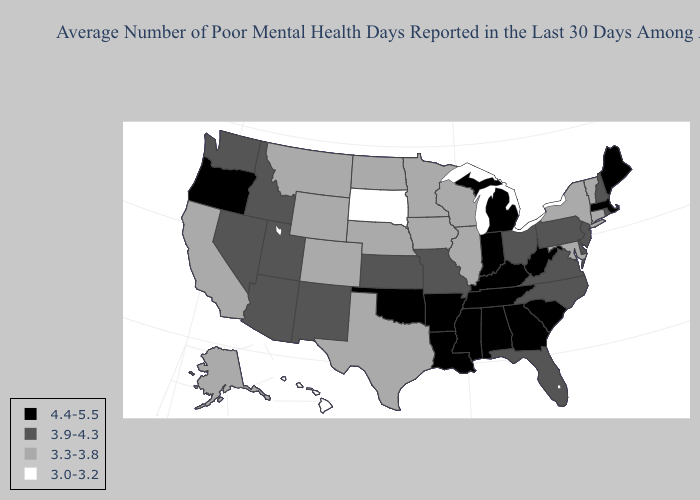What is the value of Montana?
Keep it brief. 3.3-3.8. Name the states that have a value in the range 3.0-3.2?
Be succinct. Hawaii, South Dakota. Does Hawaii have a lower value than South Dakota?
Write a very short answer. No. Does New Mexico have the same value as Pennsylvania?
Quick response, please. Yes. Among the states that border Colorado , which have the lowest value?
Give a very brief answer. Nebraska, Wyoming. How many symbols are there in the legend?
Be succinct. 4. What is the value of South Dakota?
Quick response, please. 3.0-3.2. What is the highest value in the USA?
Keep it brief. 4.4-5.5. Does the map have missing data?
Write a very short answer. No. Does North Carolina have the same value as Kentucky?
Answer briefly. No. What is the value of Missouri?
Quick response, please. 3.9-4.3. Does the map have missing data?
Write a very short answer. No. What is the highest value in states that border Pennsylvania?
Answer briefly. 4.4-5.5. Does Arkansas have the highest value in the USA?
Concise answer only. Yes. 